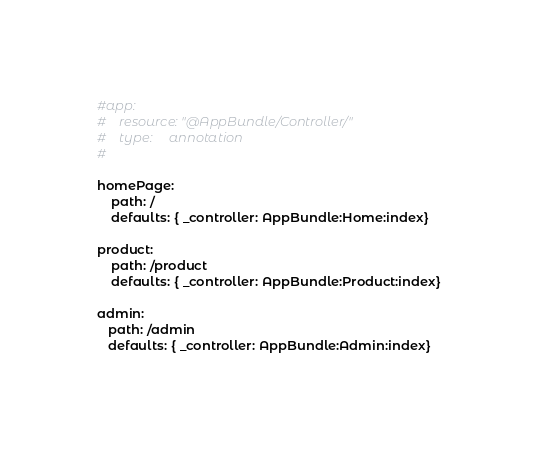Convert code to text. <code><loc_0><loc_0><loc_500><loc_500><_YAML_>#app:
#    resource: "@AppBundle/Controller/"
#    type:     annotation
#

homePage:
    path: /
    defaults: { _controller: AppBundle:Home:index}

product:
    path: /product
    defaults: { _controller: AppBundle:Product:index}

admin:
   path: /admin
   defaults: { _controller: AppBundle:Admin:index}</code> 